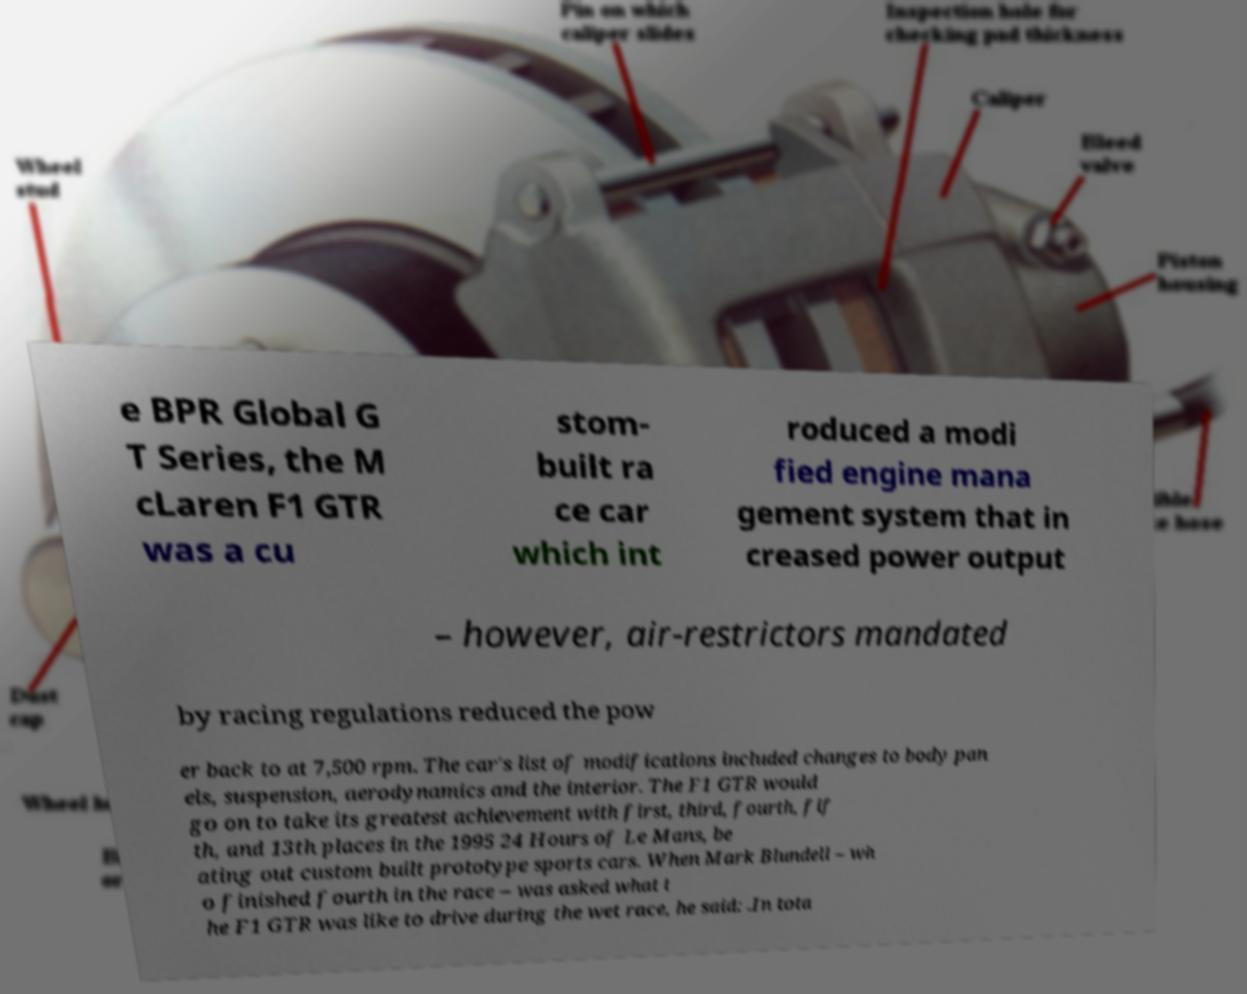Could you extract and type out the text from this image? e BPR Global G T Series, the M cLaren F1 GTR was a cu stom- built ra ce car which int roduced a modi fied engine mana gement system that in creased power output – however, air-restrictors mandated by racing regulations reduced the pow er back to at 7,500 rpm. The car's list of modifications included changes to body pan els, suspension, aerodynamics and the interior. The F1 GTR would go on to take its greatest achievement with first, third, fourth, fif th, and 13th places in the 1995 24 Hours of Le Mans, be ating out custom built prototype sports cars. When Mark Blundell – wh o finished fourth in the race – was asked what t he F1 GTR was like to drive during the wet race, he said: .In tota 